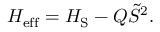Convert formula to latex. <formula><loc_0><loc_0><loc_500><loc_500>\begin{array} { r } { H _ { e f f } = H _ { S } - Q \tilde { S } ^ { 2 } . } \end{array}</formula> 